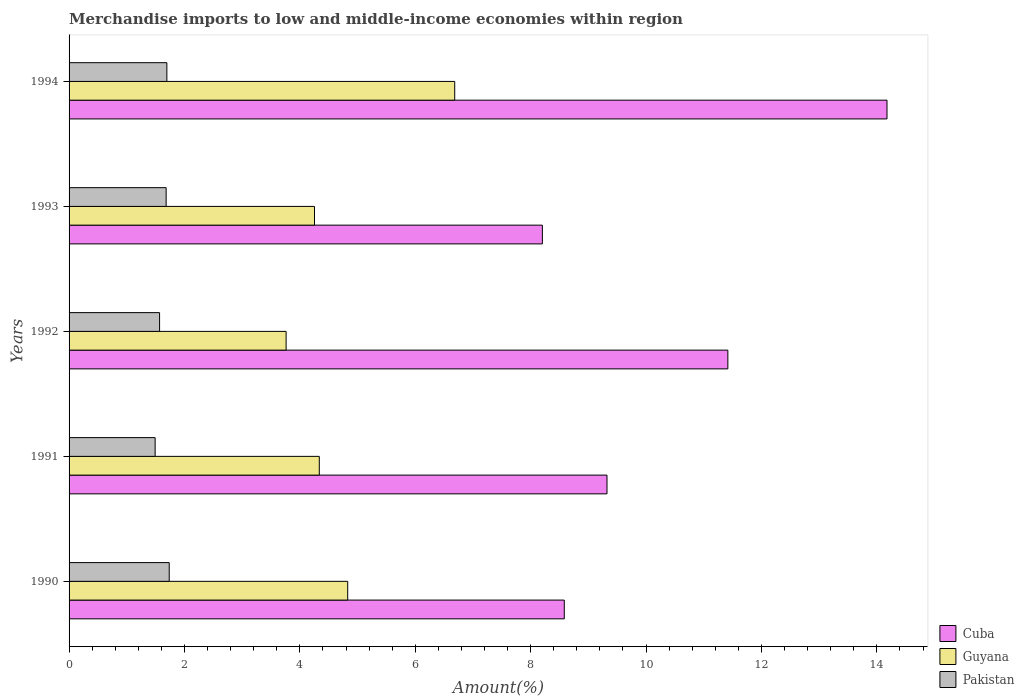Are the number of bars per tick equal to the number of legend labels?
Ensure brevity in your answer.  Yes. How many bars are there on the 4th tick from the top?
Keep it short and to the point. 3. What is the label of the 1st group of bars from the top?
Your response must be concise. 1994. What is the percentage of amount earned from merchandise imports in Cuba in 1993?
Your response must be concise. 8.2. Across all years, what is the maximum percentage of amount earned from merchandise imports in Pakistan?
Make the answer very short. 1.74. Across all years, what is the minimum percentage of amount earned from merchandise imports in Pakistan?
Provide a short and direct response. 1.49. In which year was the percentage of amount earned from merchandise imports in Cuba maximum?
Offer a very short reply. 1994. In which year was the percentage of amount earned from merchandise imports in Pakistan minimum?
Make the answer very short. 1991. What is the total percentage of amount earned from merchandise imports in Cuba in the graph?
Your answer should be very brief. 51.7. What is the difference between the percentage of amount earned from merchandise imports in Guyana in 1991 and that in 1993?
Provide a succinct answer. 0.08. What is the difference between the percentage of amount earned from merchandise imports in Guyana in 1990 and the percentage of amount earned from merchandise imports in Cuba in 1994?
Your answer should be very brief. -9.35. What is the average percentage of amount earned from merchandise imports in Pakistan per year?
Make the answer very short. 1.63. In the year 1991, what is the difference between the percentage of amount earned from merchandise imports in Pakistan and percentage of amount earned from merchandise imports in Guyana?
Give a very brief answer. -2.85. In how many years, is the percentage of amount earned from merchandise imports in Cuba greater than 2.8 %?
Give a very brief answer. 5. What is the ratio of the percentage of amount earned from merchandise imports in Guyana in 1992 to that in 1994?
Give a very brief answer. 0.56. What is the difference between the highest and the second highest percentage of amount earned from merchandise imports in Cuba?
Your response must be concise. 2.76. What is the difference between the highest and the lowest percentage of amount earned from merchandise imports in Cuba?
Provide a succinct answer. 5.97. Is the sum of the percentage of amount earned from merchandise imports in Pakistan in 1992 and 1994 greater than the maximum percentage of amount earned from merchandise imports in Cuba across all years?
Offer a very short reply. No. What does the 3rd bar from the top in 1994 represents?
Your response must be concise. Cuba. What does the 2nd bar from the bottom in 1990 represents?
Your answer should be compact. Guyana. Are all the bars in the graph horizontal?
Offer a very short reply. Yes. What is the difference between two consecutive major ticks on the X-axis?
Your answer should be very brief. 2. Are the values on the major ticks of X-axis written in scientific E-notation?
Ensure brevity in your answer.  No. Does the graph contain any zero values?
Your response must be concise. No. Where does the legend appear in the graph?
Your response must be concise. Bottom right. How many legend labels are there?
Provide a short and direct response. 3. What is the title of the graph?
Keep it short and to the point. Merchandise imports to low and middle-income economies within region. What is the label or title of the X-axis?
Ensure brevity in your answer.  Amount(%). What is the Amount(%) in Cuba in 1990?
Provide a short and direct response. 8.58. What is the Amount(%) of Guyana in 1990?
Offer a very short reply. 4.83. What is the Amount(%) of Pakistan in 1990?
Offer a very short reply. 1.74. What is the Amount(%) of Cuba in 1991?
Your response must be concise. 9.32. What is the Amount(%) in Guyana in 1991?
Your answer should be compact. 4.34. What is the Amount(%) of Pakistan in 1991?
Keep it short and to the point. 1.49. What is the Amount(%) in Cuba in 1992?
Provide a succinct answer. 11.42. What is the Amount(%) in Guyana in 1992?
Your answer should be very brief. 3.76. What is the Amount(%) of Pakistan in 1992?
Offer a very short reply. 1.57. What is the Amount(%) in Cuba in 1993?
Offer a very short reply. 8.2. What is the Amount(%) in Guyana in 1993?
Offer a very short reply. 4.25. What is the Amount(%) of Pakistan in 1993?
Offer a terse response. 1.68. What is the Amount(%) of Cuba in 1994?
Keep it short and to the point. 14.18. What is the Amount(%) of Guyana in 1994?
Offer a very short reply. 6.68. What is the Amount(%) of Pakistan in 1994?
Offer a very short reply. 1.69. Across all years, what is the maximum Amount(%) of Cuba?
Offer a very short reply. 14.18. Across all years, what is the maximum Amount(%) of Guyana?
Make the answer very short. 6.68. Across all years, what is the maximum Amount(%) of Pakistan?
Make the answer very short. 1.74. Across all years, what is the minimum Amount(%) of Cuba?
Keep it short and to the point. 8.2. Across all years, what is the minimum Amount(%) in Guyana?
Make the answer very short. 3.76. Across all years, what is the minimum Amount(%) of Pakistan?
Your answer should be compact. 1.49. What is the total Amount(%) of Cuba in the graph?
Your answer should be very brief. 51.7. What is the total Amount(%) in Guyana in the graph?
Keep it short and to the point. 23.86. What is the total Amount(%) of Pakistan in the graph?
Offer a very short reply. 8.17. What is the difference between the Amount(%) of Cuba in 1990 and that in 1991?
Your answer should be compact. -0.74. What is the difference between the Amount(%) in Guyana in 1990 and that in 1991?
Your answer should be compact. 0.49. What is the difference between the Amount(%) in Pakistan in 1990 and that in 1991?
Keep it short and to the point. 0.24. What is the difference between the Amount(%) of Cuba in 1990 and that in 1992?
Provide a short and direct response. -2.83. What is the difference between the Amount(%) of Guyana in 1990 and that in 1992?
Keep it short and to the point. 1.07. What is the difference between the Amount(%) in Pakistan in 1990 and that in 1992?
Offer a very short reply. 0.17. What is the difference between the Amount(%) in Cuba in 1990 and that in 1993?
Offer a very short reply. 0.38. What is the difference between the Amount(%) in Guyana in 1990 and that in 1993?
Provide a short and direct response. 0.58. What is the difference between the Amount(%) in Pakistan in 1990 and that in 1993?
Offer a terse response. 0.05. What is the difference between the Amount(%) of Cuba in 1990 and that in 1994?
Make the answer very short. -5.59. What is the difference between the Amount(%) in Guyana in 1990 and that in 1994?
Your response must be concise. -1.85. What is the difference between the Amount(%) of Pakistan in 1990 and that in 1994?
Provide a succinct answer. 0.04. What is the difference between the Amount(%) in Cuba in 1991 and that in 1992?
Your response must be concise. -2.09. What is the difference between the Amount(%) of Guyana in 1991 and that in 1992?
Your answer should be compact. 0.58. What is the difference between the Amount(%) in Pakistan in 1991 and that in 1992?
Offer a terse response. -0.08. What is the difference between the Amount(%) of Cuba in 1991 and that in 1993?
Make the answer very short. 1.12. What is the difference between the Amount(%) in Guyana in 1991 and that in 1993?
Provide a short and direct response. 0.08. What is the difference between the Amount(%) in Pakistan in 1991 and that in 1993?
Offer a very short reply. -0.19. What is the difference between the Amount(%) in Cuba in 1991 and that in 1994?
Provide a short and direct response. -4.85. What is the difference between the Amount(%) of Guyana in 1991 and that in 1994?
Offer a terse response. -2.35. What is the difference between the Amount(%) in Pakistan in 1991 and that in 1994?
Your answer should be compact. -0.2. What is the difference between the Amount(%) in Cuba in 1992 and that in 1993?
Ensure brevity in your answer.  3.21. What is the difference between the Amount(%) in Guyana in 1992 and that in 1993?
Offer a terse response. -0.49. What is the difference between the Amount(%) of Pakistan in 1992 and that in 1993?
Your answer should be compact. -0.11. What is the difference between the Amount(%) of Cuba in 1992 and that in 1994?
Provide a short and direct response. -2.76. What is the difference between the Amount(%) in Guyana in 1992 and that in 1994?
Provide a short and direct response. -2.92. What is the difference between the Amount(%) of Pakistan in 1992 and that in 1994?
Your response must be concise. -0.13. What is the difference between the Amount(%) of Cuba in 1993 and that in 1994?
Give a very brief answer. -5.97. What is the difference between the Amount(%) in Guyana in 1993 and that in 1994?
Make the answer very short. -2.43. What is the difference between the Amount(%) in Pakistan in 1993 and that in 1994?
Provide a succinct answer. -0.01. What is the difference between the Amount(%) in Cuba in 1990 and the Amount(%) in Guyana in 1991?
Offer a terse response. 4.25. What is the difference between the Amount(%) in Cuba in 1990 and the Amount(%) in Pakistan in 1991?
Provide a succinct answer. 7.09. What is the difference between the Amount(%) in Guyana in 1990 and the Amount(%) in Pakistan in 1991?
Your answer should be compact. 3.34. What is the difference between the Amount(%) in Cuba in 1990 and the Amount(%) in Guyana in 1992?
Your answer should be very brief. 4.82. What is the difference between the Amount(%) in Cuba in 1990 and the Amount(%) in Pakistan in 1992?
Your response must be concise. 7.01. What is the difference between the Amount(%) in Guyana in 1990 and the Amount(%) in Pakistan in 1992?
Provide a short and direct response. 3.26. What is the difference between the Amount(%) in Cuba in 1990 and the Amount(%) in Guyana in 1993?
Your response must be concise. 4.33. What is the difference between the Amount(%) of Cuba in 1990 and the Amount(%) of Pakistan in 1993?
Offer a very short reply. 6.9. What is the difference between the Amount(%) of Guyana in 1990 and the Amount(%) of Pakistan in 1993?
Provide a short and direct response. 3.15. What is the difference between the Amount(%) in Cuba in 1990 and the Amount(%) in Guyana in 1994?
Your response must be concise. 1.9. What is the difference between the Amount(%) of Cuba in 1990 and the Amount(%) of Pakistan in 1994?
Ensure brevity in your answer.  6.89. What is the difference between the Amount(%) of Guyana in 1990 and the Amount(%) of Pakistan in 1994?
Your answer should be compact. 3.13. What is the difference between the Amount(%) of Cuba in 1991 and the Amount(%) of Guyana in 1992?
Provide a succinct answer. 5.56. What is the difference between the Amount(%) of Cuba in 1991 and the Amount(%) of Pakistan in 1992?
Keep it short and to the point. 7.75. What is the difference between the Amount(%) of Guyana in 1991 and the Amount(%) of Pakistan in 1992?
Offer a very short reply. 2.77. What is the difference between the Amount(%) of Cuba in 1991 and the Amount(%) of Guyana in 1993?
Offer a terse response. 5.07. What is the difference between the Amount(%) of Cuba in 1991 and the Amount(%) of Pakistan in 1993?
Your answer should be very brief. 7.64. What is the difference between the Amount(%) of Guyana in 1991 and the Amount(%) of Pakistan in 1993?
Your answer should be very brief. 2.65. What is the difference between the Amount(%) of Cuba in 1991 and the Amount(%) of Guyana in 1994?
Your response must be concise. 2.64. What is the difference between the Amount(%) in Cuba in 1991 and the Amount(%) in Pakistan in 1994?
Your answer should be very brief. 7.63. What is the difference between the Amount(%) of Guyana in 1991 and the Amount(%) of Pakistan in 1994?
Offer a terse response. 2.64. What is the difference between the Amount(%) of Cuba in 1992 and the Amount(%) of Guyana in 1993?
Offer a very short reply. 7.16. What is the difference between the Amount(%) of Cuba in 1992 and the Amount(%) of Pakistan in 1993?
Provide a succinct answer. 9.74. What is the difference between the Amount(%) in Guyana in 1992 and the Amount(%) in Pakistan in 1993?
Offer a very short reply. 2.08. What is the difference between the Amount(%) in Cuba in 1992 and the Amount(%) in Guyana in 1994?
Offer a terse response. 4.73. What is the difference between the Amount(%) in Cuba in 1992 and the Amount(%) in Pakistan in 1994?
Keep it short and to the point. 9.72. What is the difference between the Amount(%) in Guyana in 1992 and the Amount(%) in Pakistan in 1994?
Make the answer very short. 2.07. What is the difference between the Amount(%) of Cuba in 1993 and the Amount(%) of Guyana in 1994?
Provide a short and direct response. 1.52. What is the difference between the Amount(%) of Cuba in 1993 and the Amount(%) of Pakistan in 1994?
Your answer should be compact. 6.51. What is the difference between the Amount(%) of Guyana in 1993 and the Amount(%) of Pakistan in 1994?
Your answer should be compact. 2.56. What is the average Amount(%) of Cuba per year?
Your answer should be very brief. 10.34. What is the average Amount(%) in Guyana per year?
Offer a terse response. 4.77. What is the average Amount(%) of Pakistan per year?
Ensure brevity in your answer.  1.63. In the year 1990, what is the difference between the Amount(%) of Cuba and Amount(%) of Guyana?
Provide a short and direct response. 3.75. In the year 1990, what is the difference between the Amount(%) in Cuba and Amount(%) in Pakistan?
Your response must be concise. 6.85. In the year 1990, what is the difference between the Amount(%) in Guyana and Amount(%) in Pakistan?
Make the answer very short. 3.09. In the year 1991, what is the difference between the Amount(%) of Cuba and Amount(%) of Guyana?
Keep it short and to the point. 4.99. In the year 1991, what is the difference between the Amount(%) in Cuba and Amount(%) in Pakistan?
Offer a terse response. 7.83. In the year 1991, what is the difference between the Amount(%) of Guyana and Amount(%) of Pakistan?
Your response must be concise. 2.85. In the year 1992, what is the difference between the Amount(%) in Cuba and Amount(%) in Guyana?
Ensure brevity in your answer.  7.66. In the year 1992, what is the difference between the Amount(%) in Cuba and Amount(%) in Pakistan?
Provide a succinct answer. 9.85. In the year 1992, what is the difference between the Amount(%) of Guyana and Amount(%) of Pakistan?
Your answer should be compact. 2.19. In the year 1993, what is the difference between the Amount(%) in Cuba and Amount(%) in Guyana?
Give a very brief answer. 3.95. In the year 1993, what is the difference between the Amount(%) of Cuba and Amount(%) of Pakistan?
Ensure brevity in your answer.  6.52. In the year 1993, what is the difference between the Amount(%) of Guyana and Amount(%) of Pakistan?
Provide a succinct answer. 2.57. In the year 1994, what is the difference between the Amount(%) of Cuba and Amount(%) of Guyana?
Offer a terse response. 7.49. In the year 1994, what is the difference between the Amount(%) in Cuba and Amount(%) in Pakistan?
Your answer should be compact. 12.48. In the year 1994, what is the difference between the Amount(%) in Guyana and Amount(%) in Pakistan?
Give a very brief answer. 4.99. What is the ratio of the Amount(%) of Cuba in 1990 to that in 1991?
Give a very brief answer. 0.92. What is the ratio of the Amount(%) in Guyana in 1990 to that in 1991?
Provide a short and direct response. 1.11. What is the ratio of the Amount(%) in Pakistan in 1990 to that in 1991?
Offer a very short reply. 1.16. What is the ratio of the Amount(%) in Cuba in 1990 to that in 1992?
Offer a very short reply. 0.75. What is the ratio of the Amount(%) in Guyana in 1990 to that in 1992?
Your response must be concise. 1.28. What is the ratio of the Amount(%) of Pakistan in 1990 to that in 1992?
Keep it short and to the point. 1.11. What is the ratio of the Amount(%) of Cuba in 1990 to that in 1993?
Provide a succinct answer. 1.05. What is the ratio of the Amount(%) in Guyana in 1990 to that in 1993?
Provide a short and direct response. 1.14. What is the ratio of the Amount(%) of Pakistan in 1990 to that in 1993?
Your answer should be compact. 1.03. What is the ratio of the Amount(%) of Cuba in 1990 to that in 1994?
Your answer should be compact. 0.61. What is the ratio of the Amount(%) of Guyana in 1990 to that in 1994?
Offer a terse response. 0.72. What is the ratio of the Amount(%) in Pakistan in 1990 to that in 1994?
Provide a succinct answer. 1.02. What is the ratio of the Amount(%) in Cuba in 1991 to that in 1992?
Make the answer very short. 0.82. What is the ratio of the Amount(%) of Guyana in 1991 to that in 1992?
Ensure brevity in your answer.  1.15. What is the ratio of the Amount(%) of Pakistan in 1991 to that in 1992?
Provide a succinct answer. 0.95. What is the ratio of the Amount(%) of Cuba in 1991 to that in 1993?
Provide a succinct answer. 1.14. What is the ratio of the Amount(%) in Guyana in 1991 to that in 1993?
Make the answer very short. 1.02. What is the ratio of the Amount(%) in Pakistan in 1991 to that in 1993?
Give a very brief answer. 0.89. What is the ratio of the Amount(%) of Cuba in 1991 to that in 1994?
Your answer should be compact. 0.66. What is the ratio of the Amount(%) in Guyana in 1991 to that in 1994?
Ensure brevity in your answer.  0.65. What is the ratio of the Amount(%) in Pakistan in 1991 to that in 1994?
Ensure brevity in your answer.  0.88. What is the ratio of the Amount(%) in Cuba in 1992 to that in 1993?
Give a very brief answer. 1.39. What is the ratio of the Amount(%) in Guyana in 1992 to that in 1993?
Offer a very short reply. 0.88. What is the ratio of the Amount(%) in Pakistan in 1992 to that in 1993?
Ensure brevity in your answer.  0.93. What is the ratio of the Amount(%) in Cuba in 1992 to that in 1994?
Offer a terse response. 0.81. What is the ratio of the Amount(%) in Guyana in 1992 to that in 1994?
Give a very brief answer. 0.56. What is the ratio of the Amount(%) of Pakistan in 1992 to that in 1994?
Your answer should be very brief. 0.93. What is the ratio of the Amount(%) in Cuba in 1993 to that in 1994?
Keep it short and to the point. 0.58. What is the ratio of the Amount(%) of Guyana in 1993 to that in 1994?
Your answer should be very brief. 0.64. What is the difference between the highest and the second highest Amount(%) in Cuba?
Provide a short and direct response. 2.76. What is the difference between the highest and the second highest Amount(%) of Guyana?
Provide a short and direct response. 1.85. What is the difference between the highest and the second highest Amount(%) of Pakistan?
Offer a very short reply. 0.04. What is the difference between the highest and the lowest Amount(%) in Cuba?
Make the answer very short. 5.97. What is the difference between the highest and the lowest Amount(%) in Guyana?
Give a very brief answer. 2.92. What is the difference between the highest and the lowest Amount(%) in Pakistan?
Offer a terse response. 0.24. 